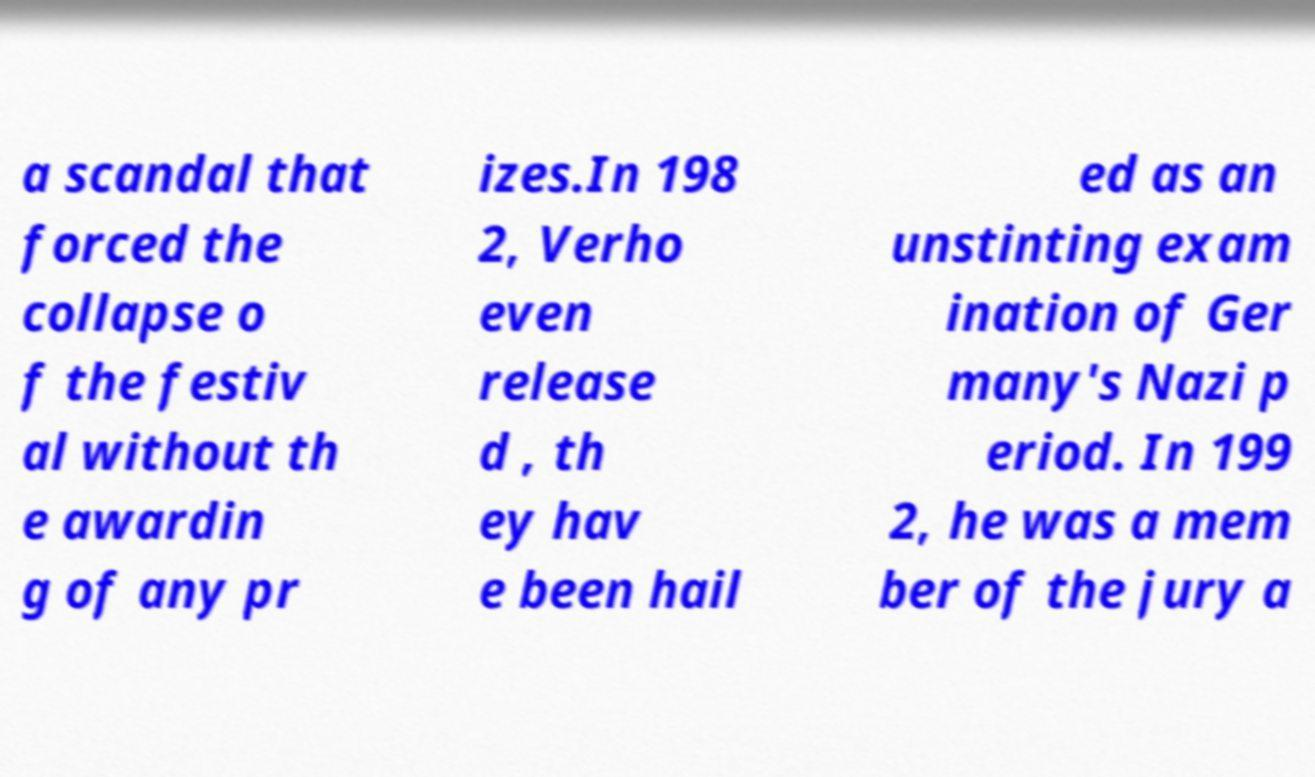What messages or text are displayed in this image? I need them in a readable, typed format. a scandal that forced the collapse o f the festiv al without th e awardin g of any pr izes.In 198 2, Verho even release d , th ey hav e been hail ed as an unstinting exam ination of Ger many's Nazi p eriod. In 199 2, he was a mem ber of the jury a 